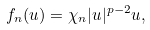<formula> <loc_0><loc_0><loc_500><loc_500>f _ { n } ( u ) = \chi _ { n } | u | ^ { p - 2 } u ,</formula> 